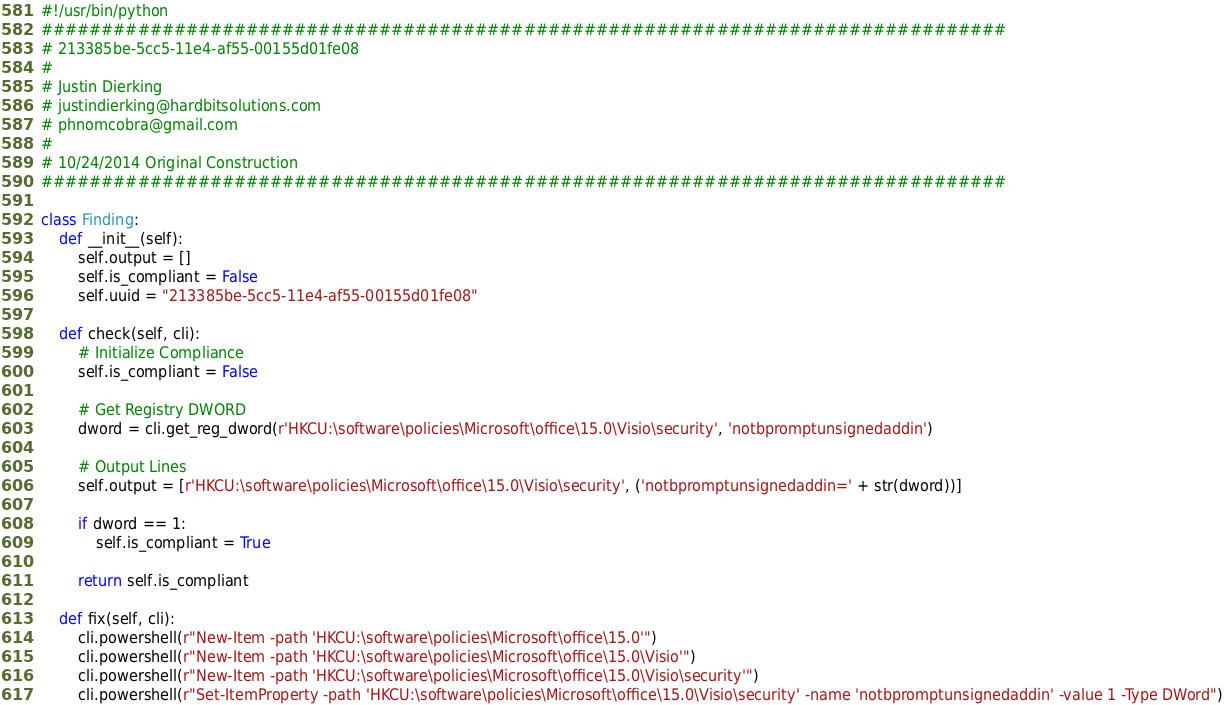Convert code to text. <code><loc_0><loc_0><loc_500><loc_500><_Python_>#!/usr/bin/python
################################################################################
# 213385be-5cc5-11e4-af55-00155d01fe08
#
# Justin Dierking
# justindierking@hardbitsolutions.com
# phnomcobra@gmail.com
#
# 10/24/2014 Original Construction
################################################################################

class Finding:
    def __init__(self):
        self.output = []
        self.is_compliant = False
        self.uuid = "213385be-5cc5-11e4-af55-00155d01fe08"
        
    def check(self, cli):
        # Initialize Compliance
        self.is_compliant = False

        # Get Registry DWORD
        dword = cli.get_reg_dword(r'HKCU:\software\policies\Microsoft\office\15.0\Visio\security', 'notbpromptunsignedaddin')

        # Output Lines
        self.output = [r'HKCU:\software\policies\Microsoft\office\15.0\Visio\security', ('notbpromptunsignedaddin=' + str(dword))]

        if dword == 1:
            self.is_compliant = True

        return self.is_compliant

    def fix(self, cli):
        cli.powershell(r"New-Item -path 'HKCU:\software\policies\Microsoft\office\15.0'")
        cli.powershell(r"New-Item -path 'HKCU:\software\policies\Microsoft\office\15.0\Visio'")
        cli.powershell(r"New-Item -path 'HKCU:\software\policies\Microsoft\office\15.0\Visio\security'")
        cli.powershell(r"Set-ItemProperty -path 'HKCU:\software\policies\Microsoft\office\15.0\Visio\security' -name 'notbpromptunsignedaddin' -value 1 -Type DWord")
</code> 